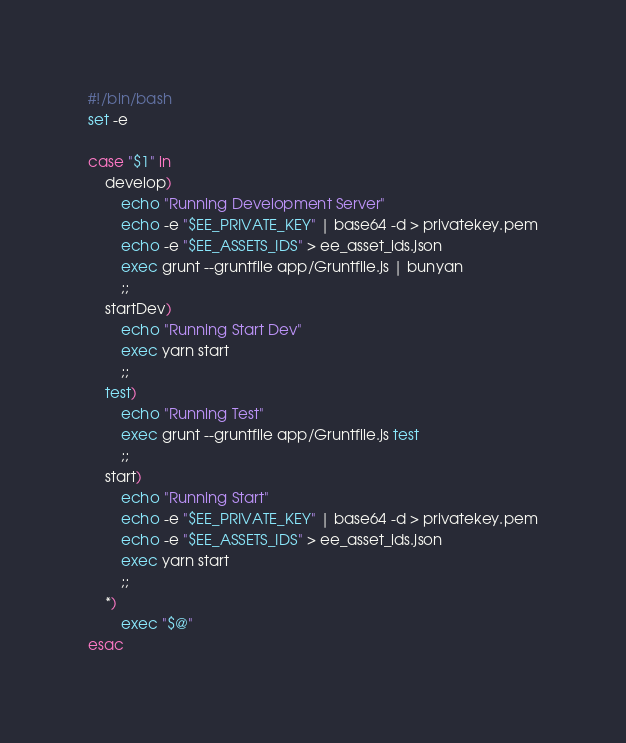<code> <loc_0><loc_0><loc_500><loc_500><_Bash_>#!/bin/bash
set -e

case "$1" in
    develop)
        echo "Running Development Server"
        echo -e "$EE_PRIVATE_KEY" | base64 -d > privatekey.pem
        echo -e "$EE_ASSETS_IDS" > ee_asset_ids.json
        exec grunt --gruntfile app/Gruntfile.js | bunyan
        ;;
    startDev)
        echo "Running Start Dev"
        exec yarn start
        ;;
    test)
        echo "Running Test"
        exec grunt --gruntfile app/Gruntfile.js test
        ;;
    start)
        echo "Running Start"
        echo -e "$EE_PRIVATE_KEY" | base64 -d > privatekey.pem
        echo -e "$EE_ASSETS_IDS" > ee_asset_ids.json
        exec yarn start
        ;;
    *)
        exec "$@"
esac
</code> 